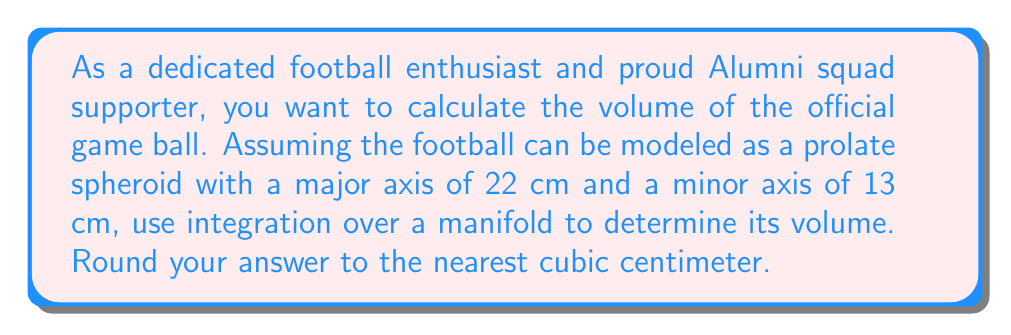Help me with this question. To calculate the volume of a football modeled as a prolate spheroid, we'll use integration over a manifold. Here's the step-by-step process:

1) A prolate spheroid is generated by rotating an ellipse around its major axis. Let's define our coordinate system such that the z-axis aligns with the major axis.

2) The equation of the ellipse in the xz-plane is:

   $$\frac{x^2}{b^2} + \frac{z^2}{a^2} = 1$$

   where $a = 11$ cm (half of the major axis) and $b = 6.5$ cm (half of the minor axis).

3) We can parameterize this surface using spherical coordinates:

   $$x = b \sin\theta \cos\phi$$
   $$y = b \sin\theta \sin\phi$$
   $$z = a \cos\theta$$

   where $0 \leq \theta \leq \pi$ and $0 \leq \phi \leq 2\pi$.

4) The volume element in spherical coordinates is:

   $$dV = r^2 \sin\theta \, d\theta \, d\phi \, dr$$

5) However, for our parameterization, $r$ is not constant. We need to find $r(\theta)$:

   $$r(\theta) = \frac{ab}{\sqrt{(b\cos\theta)^2 + (a\sin\theta)^2}}$$

6) The Jacobian determinant for our parameterization is:

   $$J = ab^2 \sin\theta$$

7) Now we can set up our volume integral:

   $$V = \int_0^{2\pi} \int_0^\pi ab^2 \sin\theta \, d\theta \, d\phi$$

8) Evaluating the integral:

   $$\begin{align*}
   V &= ab^2 \int_0^{2\pi} \int_0^\pi \sin\theta \, d\theta \, d\phi \\
   &= ab^2 \cdot 2\pi \cdot [-\cos\theta]_0^\pi \\
   &= ab^2 \cdot 2\pi \cdot 2 \\
   &= 4\pi ab^2
   \end{align*}$$

9) Substituting the values:

   $$V = 4\pi \cdot 11 \cdot (6.5)^2 = 5850.97 \text{ cm}^3$$

10) Rounding to the nearest cubic centimeter:

    $$V \approx 5851 \text{ cm}^3$$
Answer: The volume of the football is approximately 5851 cm³. 